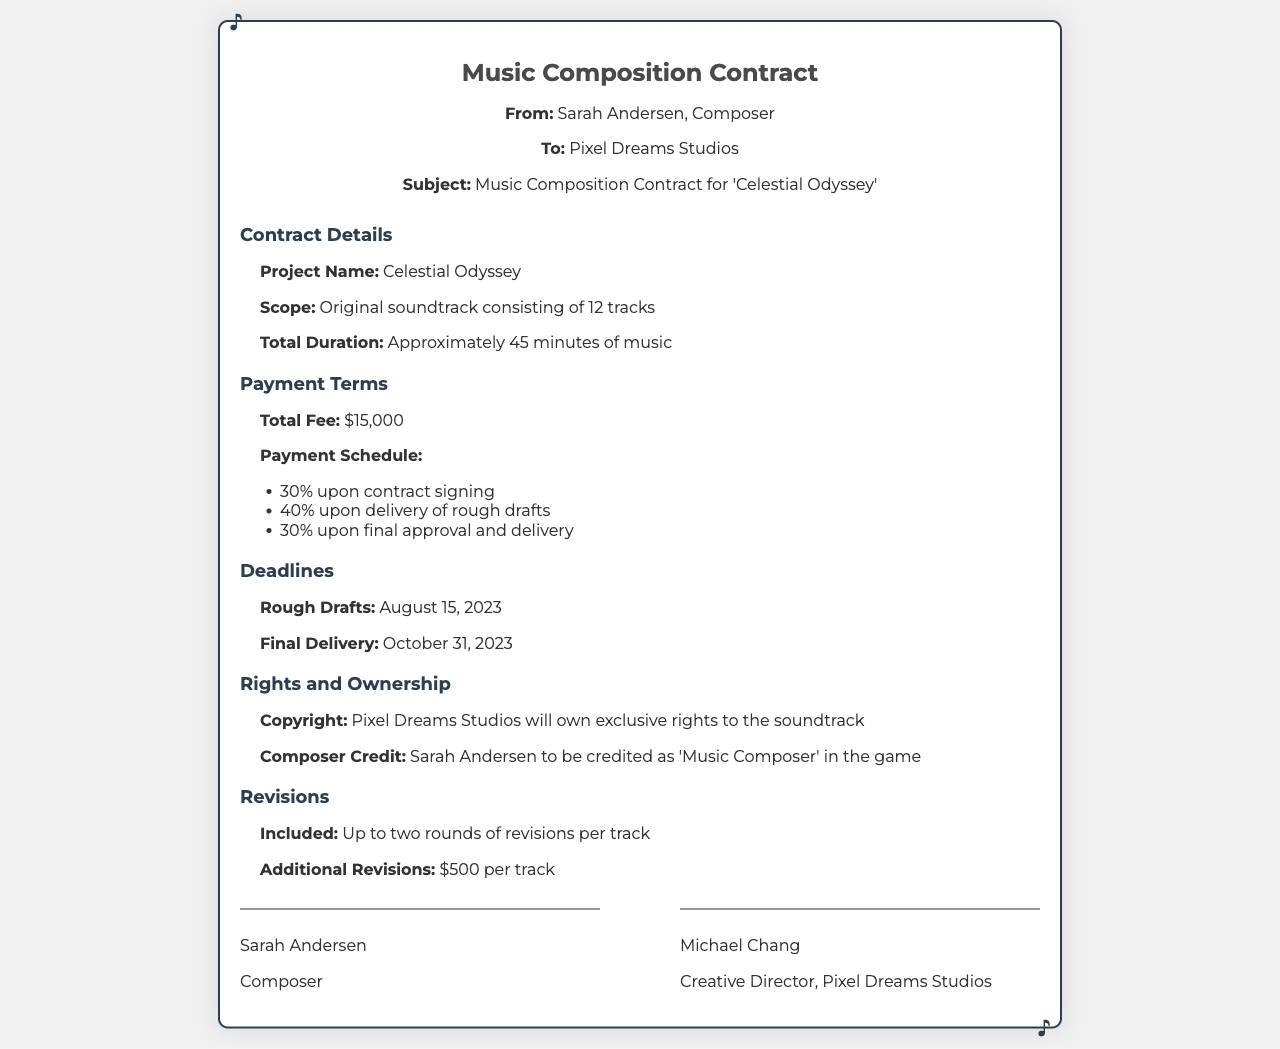What is the project name? The project name is explicitly stated in the contract details section.
Answer: Celestial Odyssey What is the total fee for the composition? The total fee is detailed under the payment terms section.
Answer: $15,000 When is the final delivery due? The final delivery deadline is specified in the deadlines section.
Answer: October 31, 2023 How many tracks will be created? The number of tracks is mentioned in the scope of the project section.
Answer: 12 tracks What percentage is paid upon contract signing? The payment schedule includes this specific percentage under payment terms.
Answer: 30% Who owns the copyright to the soundtrack? Ownership of the copyright is clearly outlined in the rights and ownership section.
Answer: Pixel Dreams Studios How many rounds of revisions are included per track? The number of included revisions can be found in the revisions section.
Answer: Up to two rounds What is the fee for additional revisions per track? The document specifies this fee in the revisions section.
Answer: $500 per track Who will be credited as the music composer in the game? The credit information is provided in the rights and ownership section.
Answer: Sarah Andersen 